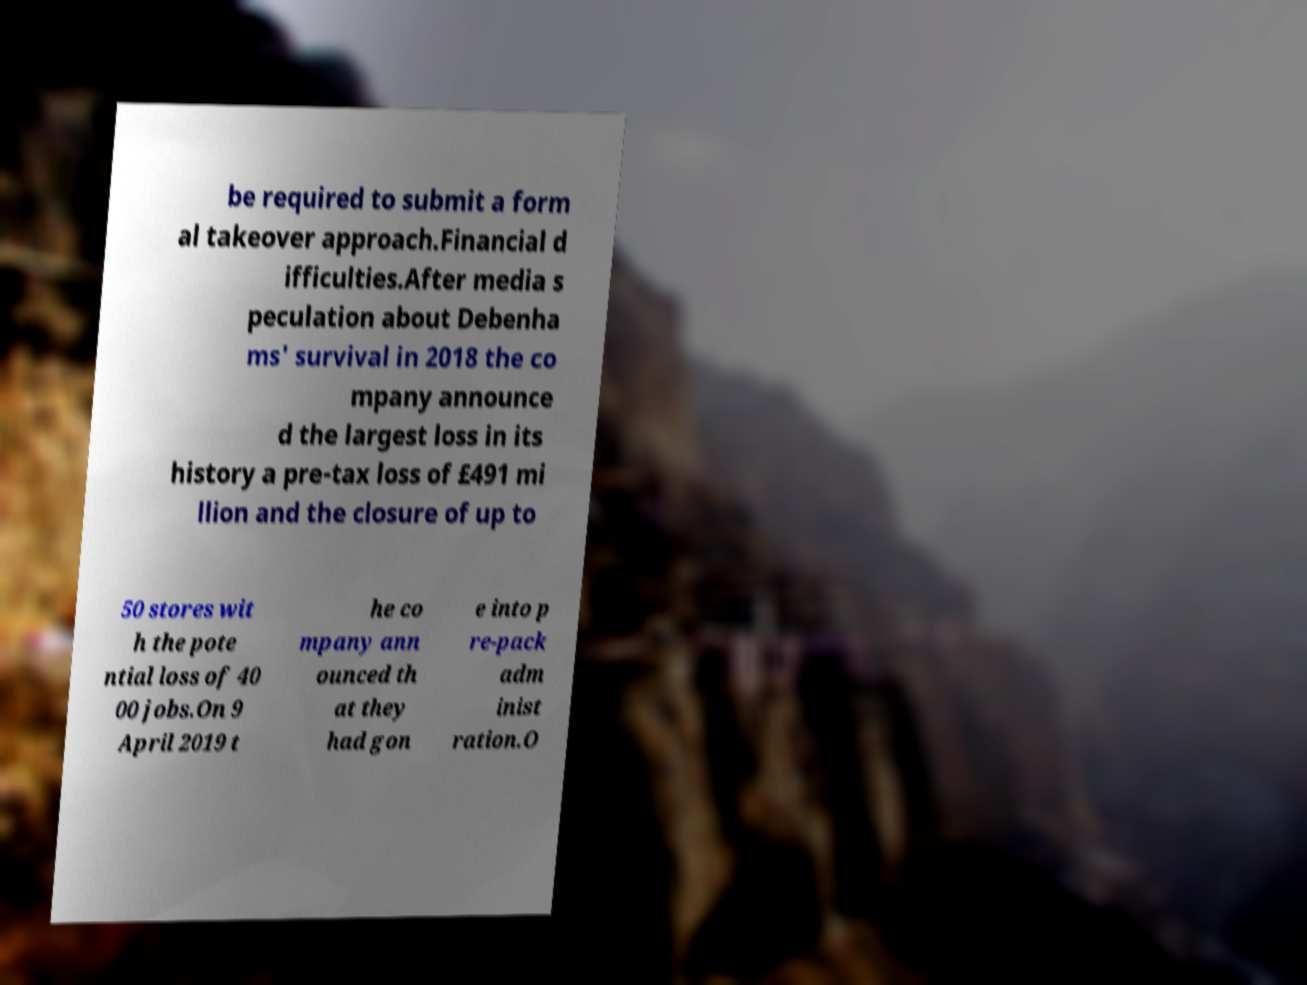I need the written content from this picture converted into text. Can you do that? be required to submit a form al takeover approach.Financial d ifficulties.After media s peculation about Debenha ms' survival in 2018 the co mpany announce d the largest loss in its history a pre-tax loss of £491 mi llion and the closure of up to 50 stores wit h the pote ntial loss of 40 00 jobs.On 9 April 2019 t he co mpany ann ounced th at they had gon e into p re-pack adm inist ration.O 